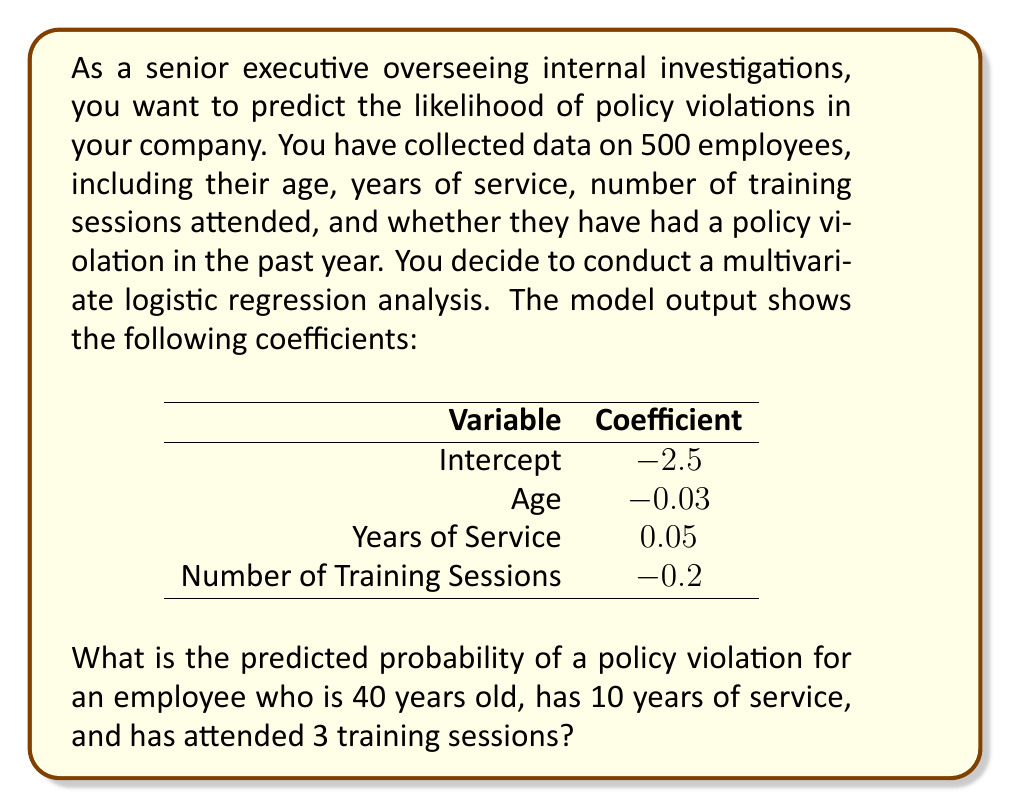Provide a solution to this math problem. To solve this problem, we need to use the logistic regression equation and the given coefficients. The logistic regression model predicts the probability of an event (in this case, a policy violation) based on multiple independent variables.

The logistic regression equation is:

$$P(Y=1) = \frac{1}{1 + e^{-z}}$$

where $z$ is the linear combination of the independent variables and their coefficients:

$$z = \beta_0 + \beta_1x_1 + \beta_2x_2 + ... + \beta_nx_n$$

Given:
- Intercept ($\beta_0$): -2.5
- Age coefficient ($\beta_1$): -0.03
- Years of Service coefficient ($\beta_2$): 0.05
- Number of Training Sessions coefficient ($\beta_3$): -0.2

For the employee in question:
- Age ($x_1$): 40
- Years of Service ($x_2$): 10
- Number of Training Sessions ($x_3$): 3

Step 1: Calculate $z$
$$z = -2.5 + (-0.03 \times 40) + (0.05 \times 10) + (-0.2 \times 3)$$
$$z = -2.5 - 1.2 + 0.5 - 0.6$$
$$z = -3.8$$

Step 2: Calculate the probability using the logistic function
$$P(Y=1) = \frac{1}{1 + e^{-(-3.8)}}$$
$$P(Y=1) = \frac{1}{1 + e^{3.8}}$$

Step 3: Evaluate the expression
$$P(Y=1) = \frac{1}{1 + 44.7012}$$
$$P(Y=1) = 0.0219$$

Therefore, the predicted probability of a policy violation for this employee is approximately 0.0219 or 2.19%.
Answer: 0.0219 or 2.19% 